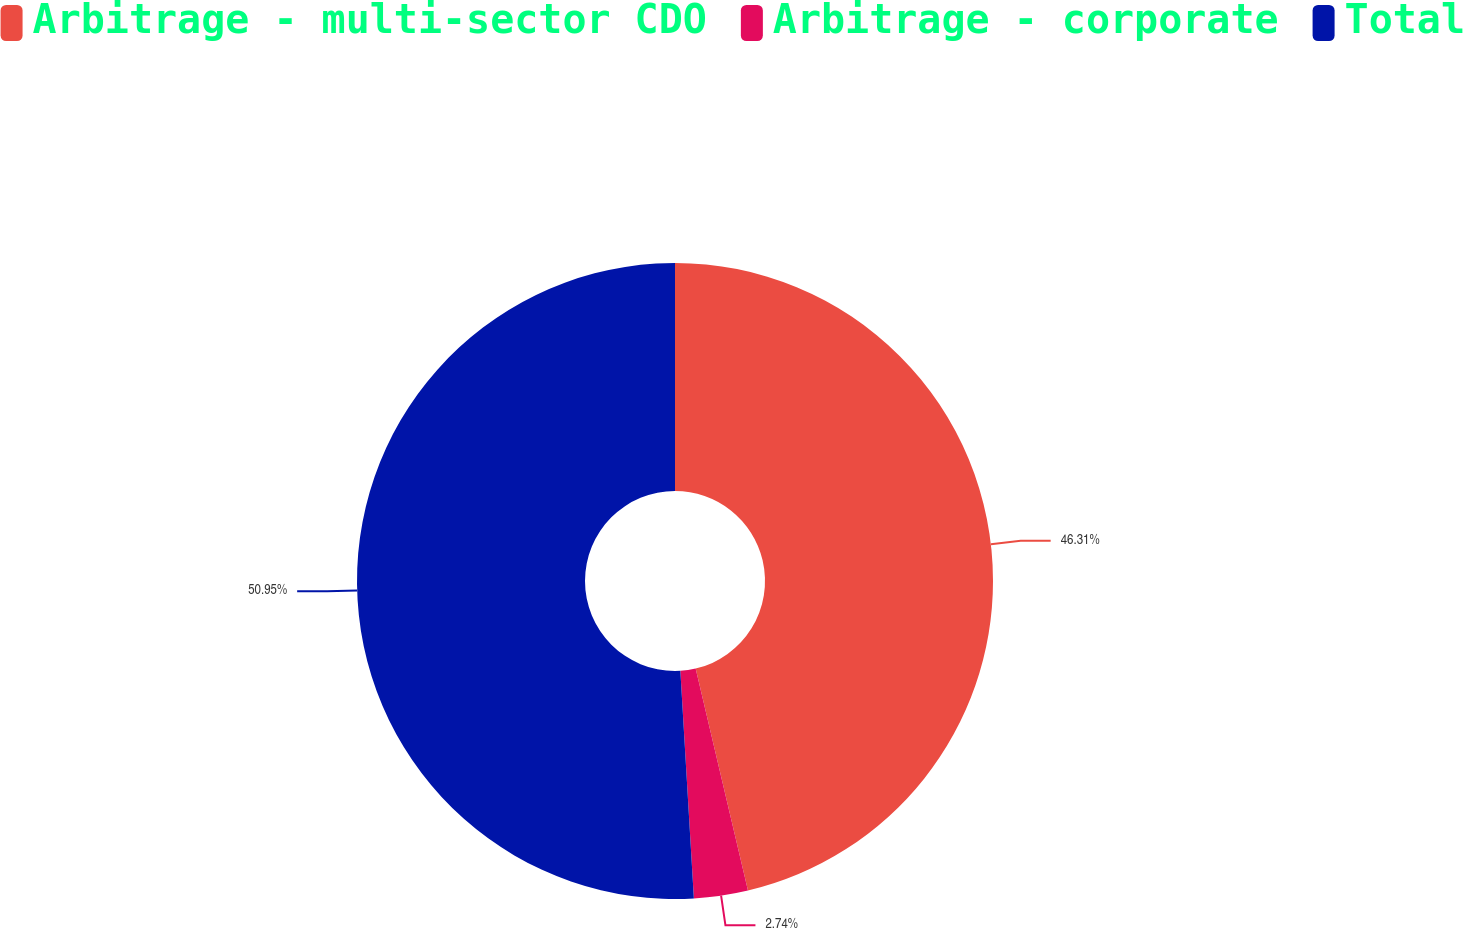<chart> <loc_0><loc_0><loc_500><loc_500><pie_chart><fcel>Arbitrage - multi-sector CDO<fcel>Arbitrage - corporate<fcel>Total<nl><fcel>46.31%<fcel>2.74%<fcel>50.94%<nl></chart> 